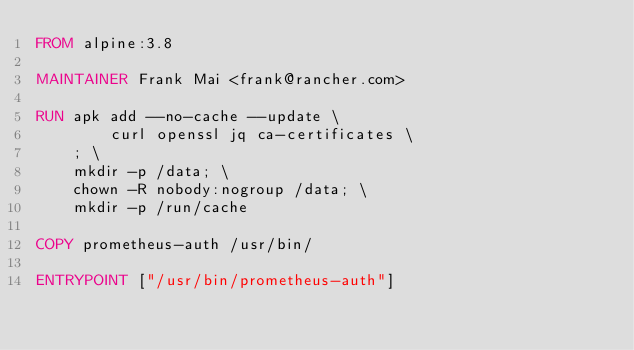<code> <loc_0><loc_0><loc_500><loc_500><_Dockerfile_>FROM alpine:3.8

MAINTAINER Frank Mai <frank@rancher.com>

RUN apk add --no-cache --update \
        curl openssl jq ca-certificates \
    ; \
    mkdir -p /data; \
    chown -R nobody:nogroup /data; \
    mkdir -p /run/cache

COPY prometheus-auth /usr/bin/

ENTRYPOINT ["/usr/bin/prometheus-auth"]</code> 